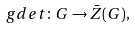<formula> <loc_0><loc_0><loc_500><loc_500>\ g d e t \colon G \to \bar { Z } ( G ) ,</formula> 